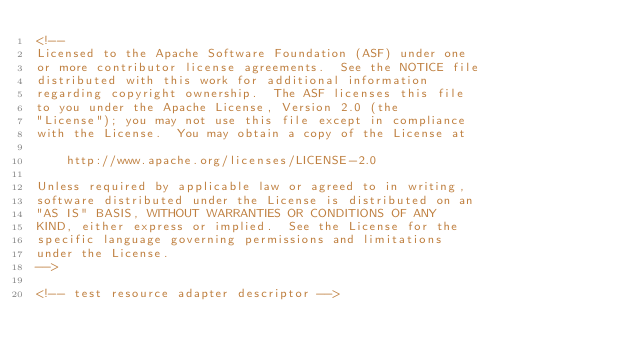Convert code to text. <code><loc_0><loc_0><loc_500><loc_500><_XML_><!--
Licensed to the Apache Software Foundation (ASF) under one
or more contributor license agreements.  See the NOTICE file
distributed with this work for additional information
regarding copyright ownership.  The ASF licenses this file
to you under the Apache License, Version 2.0 (the
"License"); you may not use this file except in compliance
with the License.  You may obtain a copy of the License at

    http://www.apache.org/licenses/LICENSE-2.0

Unless required by applicable law or agreed to in writing,
software distributed under the License is distributed on an
"AS IS" BASIS, WITHOUT WARRANTIES OR CONDITIONS OF ANY
KIND, either express or implied.  See the License for the
specific language governing permissions and limitations
under the License.
-->

<!-- test resource adapter descriptor --></code> 